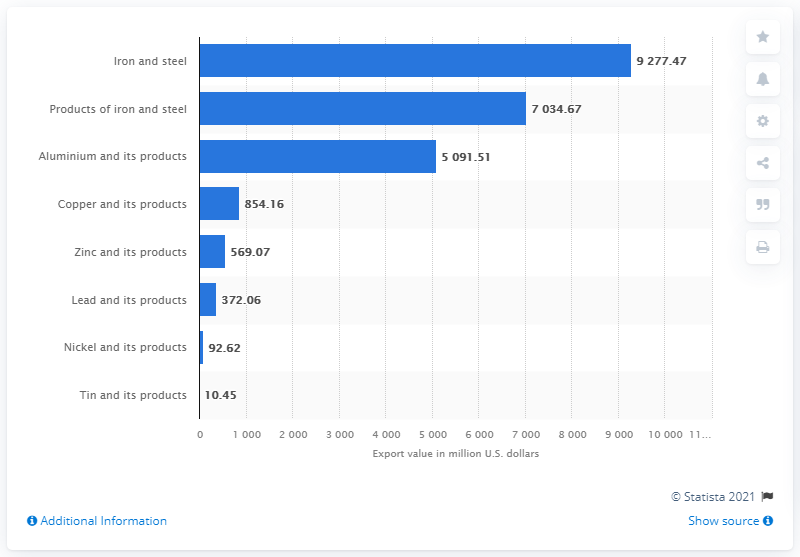Highlight a few significant elements in this photo. In the fiscal year 2020, the value of iron and steel exports from India was approximately 92,774.47 dollars. 